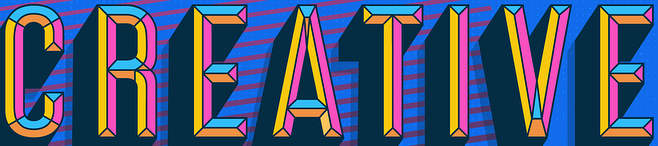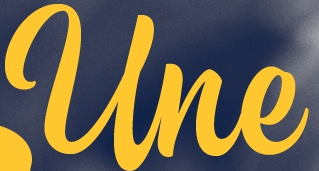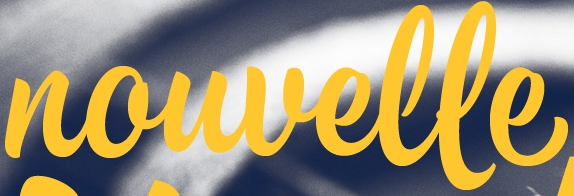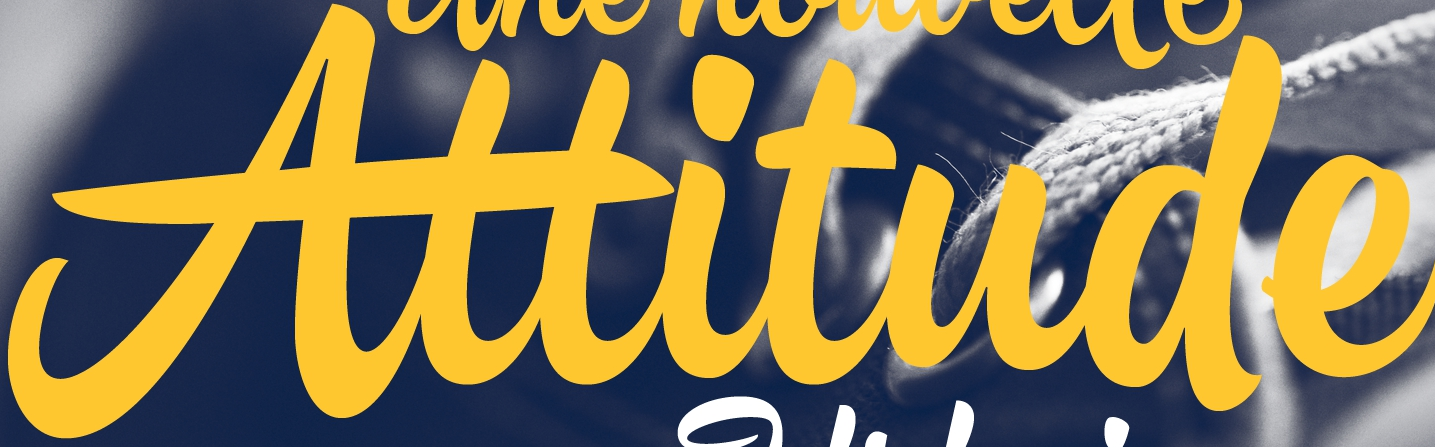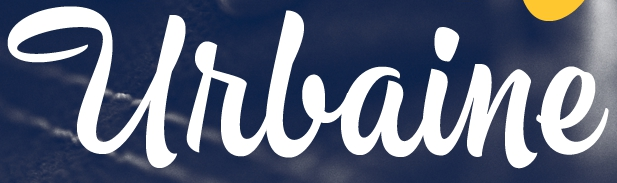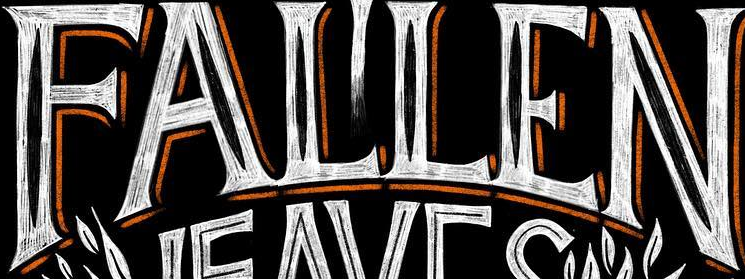Transcribe the words shown in these images in order, separated by a semicolon. CREATIVE; Une; nouvelle; Attitude; Urlaine; FALLEN 